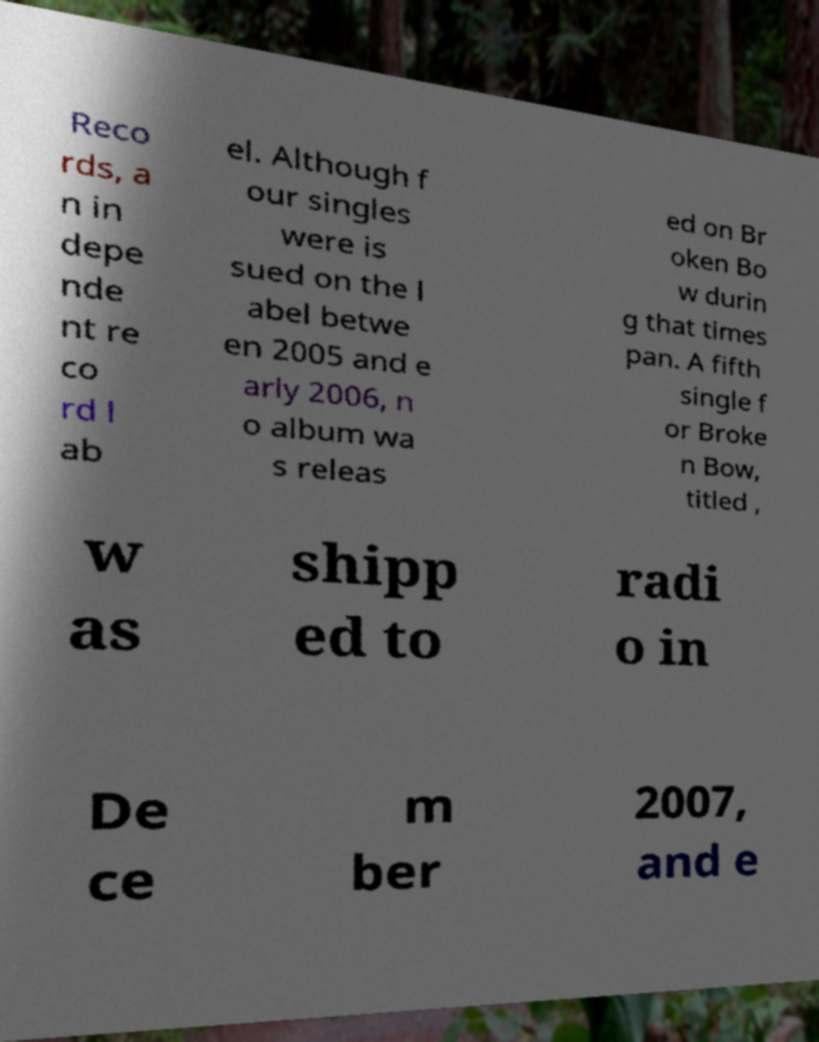Can you accurately transcribe the text from the provided image for me? Reco rds, a n in depe nde nt re co rd l ab el. Although f our singles were is sued on the l abel betwe en 2005 and e arly 2006, n o album wa s releas ed on Br oken Bo w durin g that times pan. A fifth single f or Broke n Bow, titled , w as shipp ed to radi o in De ce m ber 2007, and e 